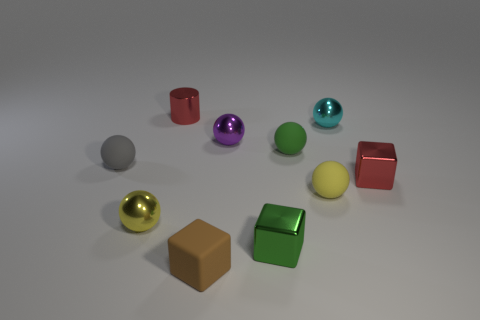What is the small red cylinder made of?
Your answer should be very brief. Metal. Is there any other thing that has the same size as the cyan metallic sphere?
Your response must be concise. Yes. What size is the red object that is the same shape as the small brown thing?
Offer a very short reply. Small. There is a matte object to the left of the red shiny cylinder; are there any small cyan metallic spheres in front of it?
Ensure brevity in your answer.  No. Is the color of the metal cylinder the same as the tiny matte block?
Give a very brief answer. No. How many other objects are there of the same shape as the brown rubber thing?
Your answer should be compact. 2. Are there more red things to the right of the green cube than red things right of the matte cube?
Make the answer very short. No. Is the size of the brown rubber object in front of the small yellow matte ball the same as the green thing in front of the gray rubber sphere?
Offer a very short reply. Yes. The tiny cyan thing has what shape?
Give a very brief answer. Sphere. There is a metallic thing that is the same color as the tiny metallic cylinder; what size is it?
Provide a short and direct response. Small. 